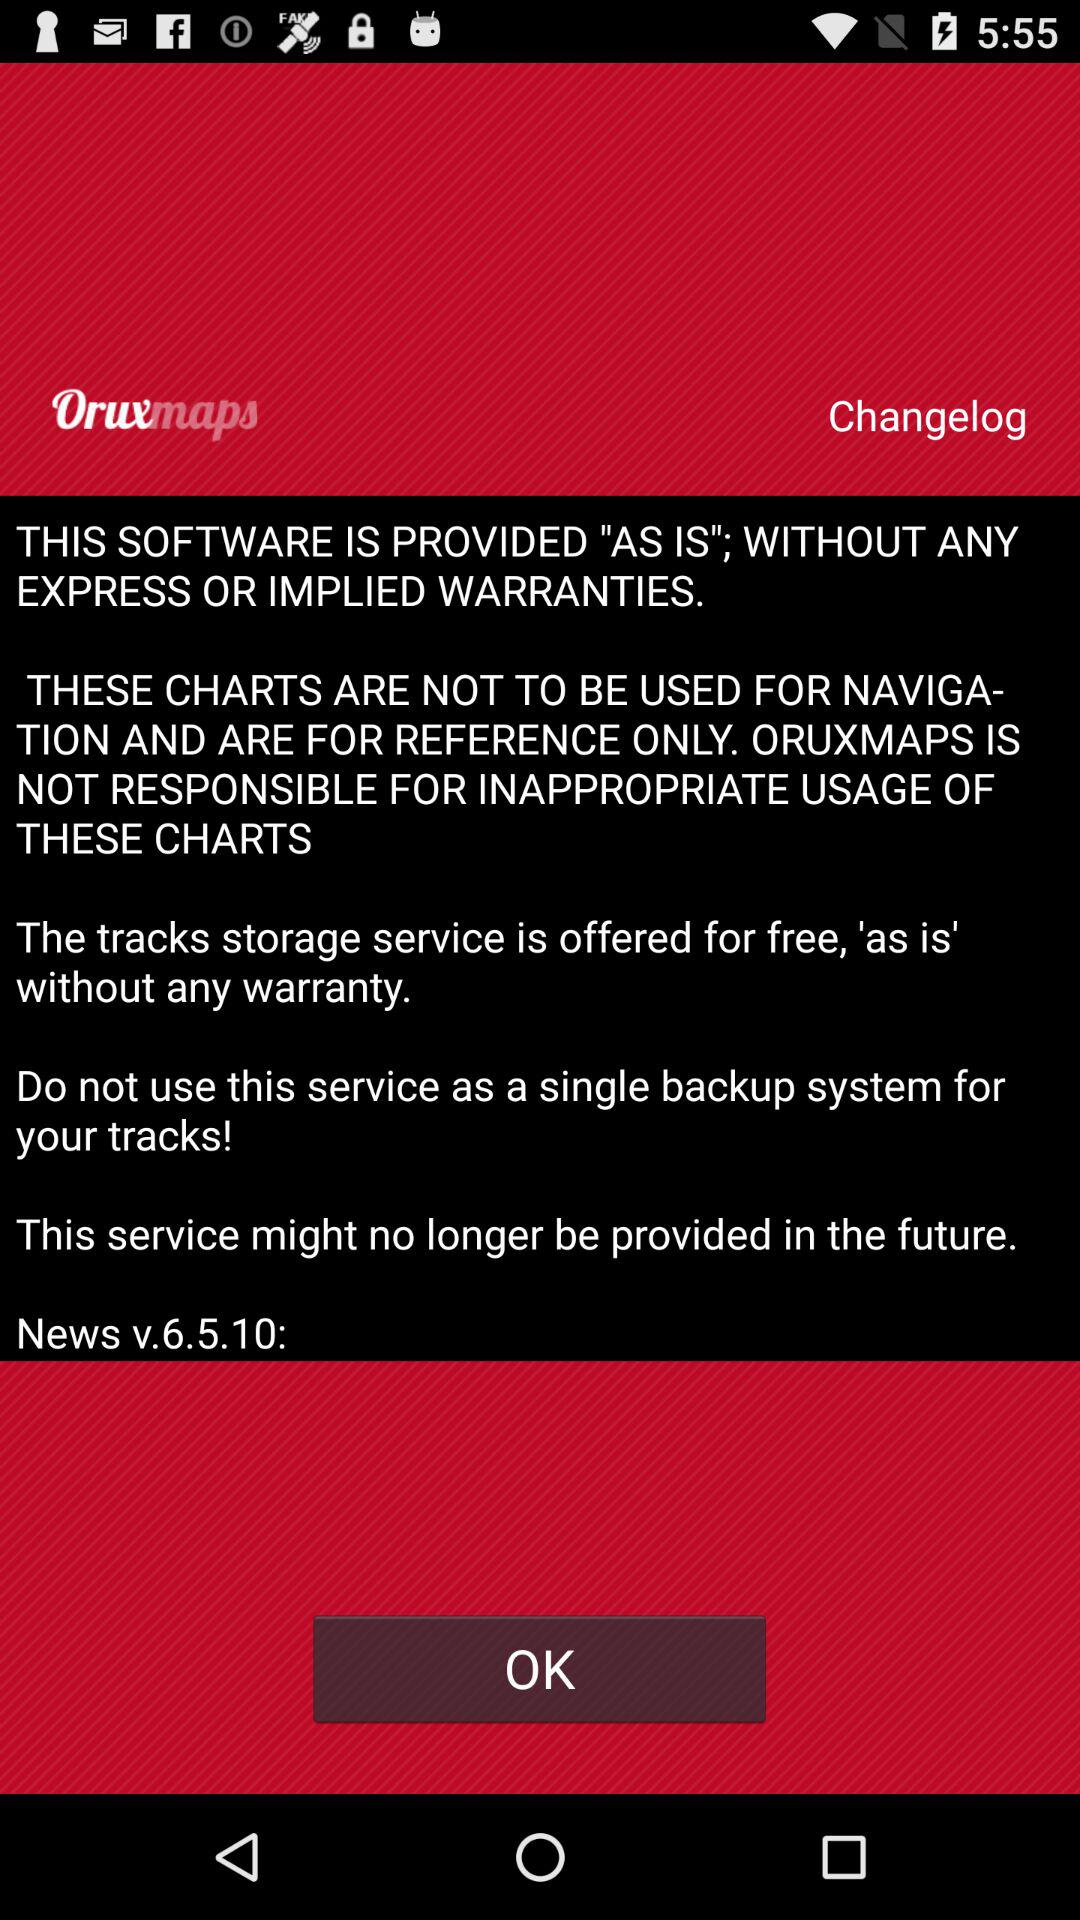What is the version of the software? The version of the software is v.6.5.10. 